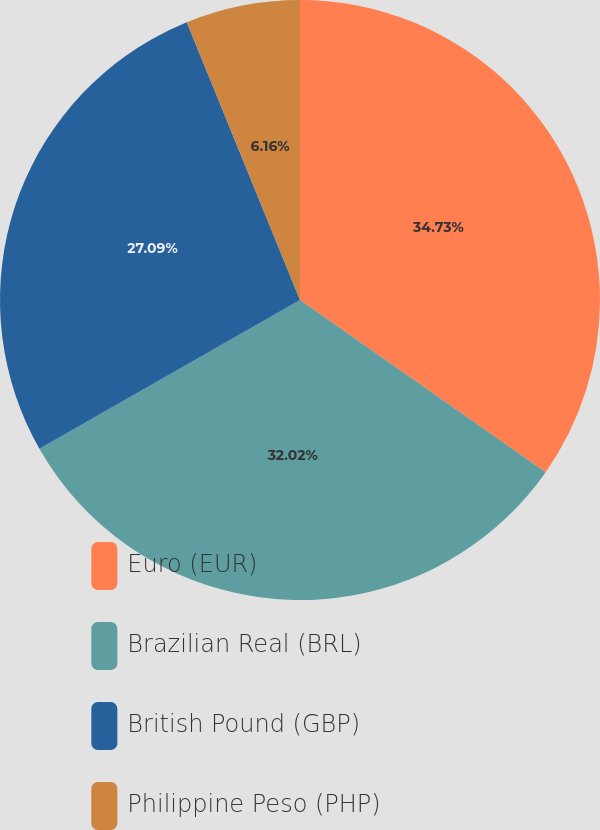Convert chart. <chart><loc_0><loc_0><loc_500><loc_500><pie_chart><fcel>Euro (EUR)<fcel>Brazilian Real (BRL)<fcel>British Pound (GBP)<fcel>Philippine Peso (PHP)<nl><fcel>34.73%<fcel>32.02%<fcel>27.09%<fcel>6.16%<nl></chart> 